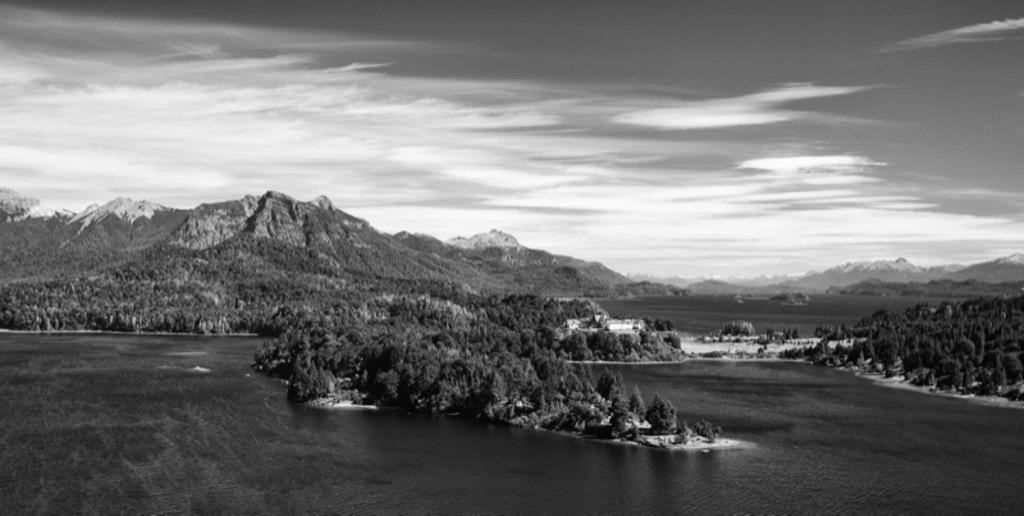Where was the image taken? The image was clicked outside the city. What can be seen in the foreground of the image? There is a water body in the foreground of the image. What type of vegetation is present in the image? There are plants and trees in the image. What geographical feature can be seen in the image? There are hills in the image. What is visible in the background of the image? The sky is visible in the background of the image. What type of invention can be seen in the image? There is no invention present in the image; it features a natural landscape with a water body, plants, trees, hills, and sky. How many robins are visible in the image? There are no robins present in the image. 